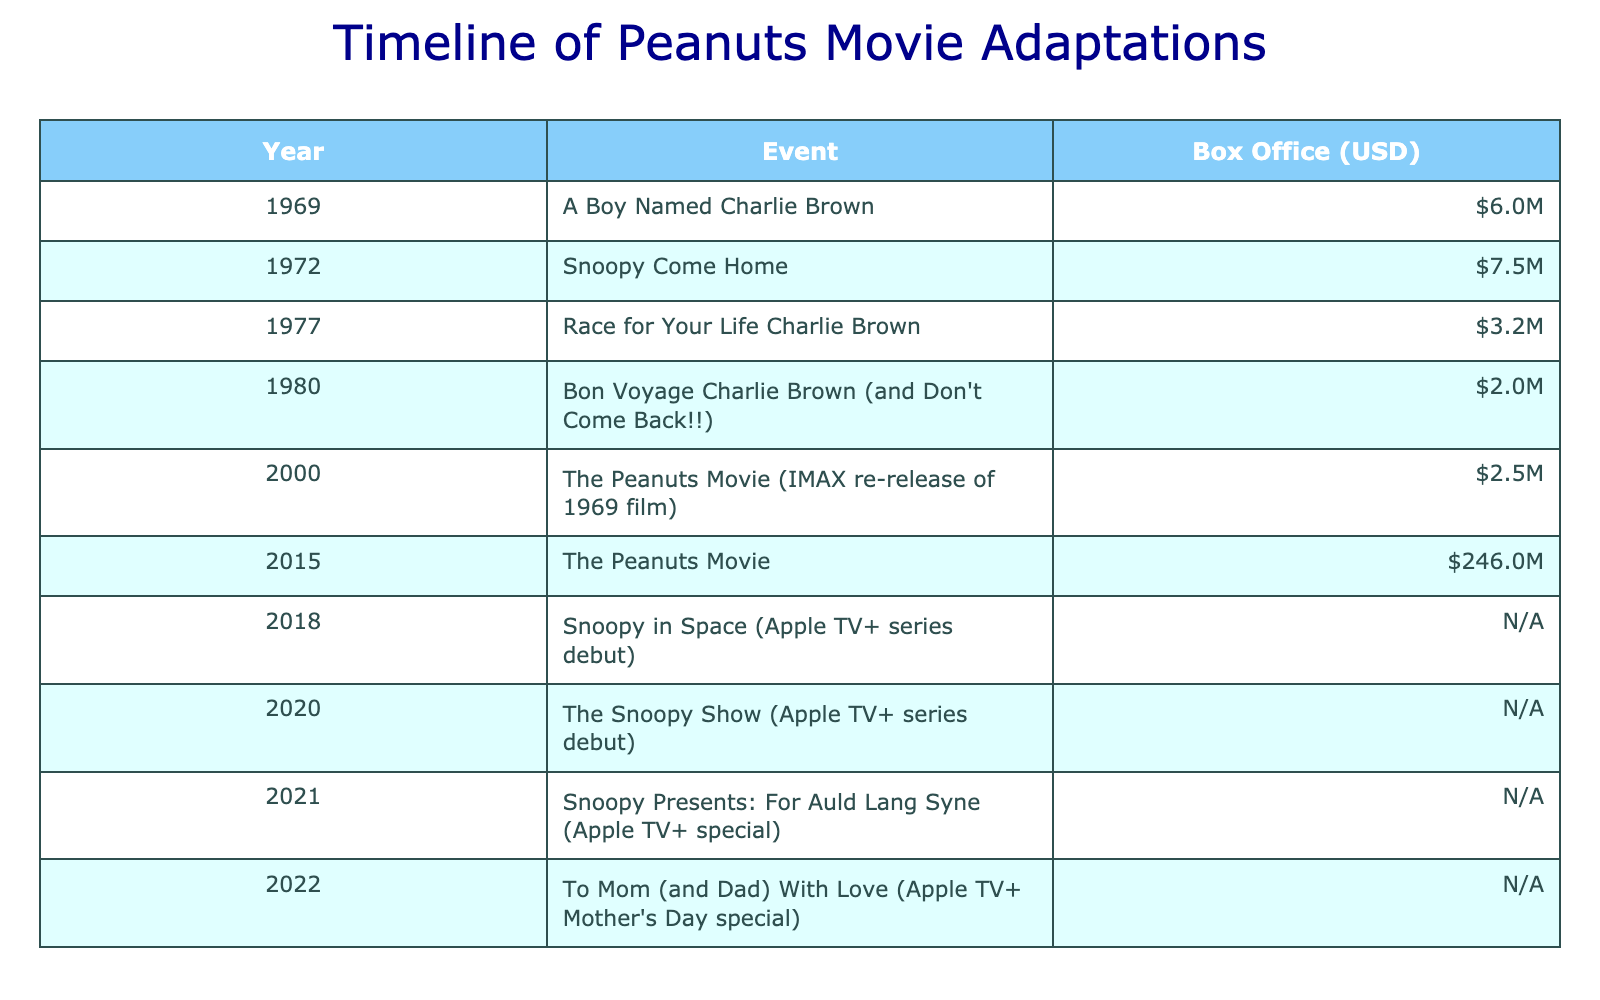What is the box office earnings for "The Peanuts Movie" released in 2015? According to the table, "The Peanuts Movie" was released in 2015 and its box office earnings are listed as 246 million USD.
Answer: 246 million How much did "Snoopy Come Home" earn at the box office? The table indicates that "Snoopy Come Home," released in 1972, earned 7.5 million USD at the box office.
Answer: 7.5 million What event had the lowest box office earnings? By reviewing the box office earnings in the table, "Bon Voyage Charlie Brown (and Don't Come Back!!)" from 1980 had the lowest earnings, at 2 million USD.
Answer: 2 million What is the total box office earnings of all the movies listed in the table? Summing the box office earnings from the movies that have values, we get: 6 + 7.5 + 3.2 + 2 + 2.5 + 246 = 267.2 million USD. Note that the adaptations without earnings are not included in this calculation.
Answer: 267.2 million Was there any movie released after 2000 that had a higher box office than "A Boy Named Charlie Brown"? "A Boy Named Charlie Brown" earned 6 million USD. In the table, "The Peanuts Movie" from 2015 earned 246 million, which is higher. So, yes, there was indeed a movie released after 2000 that had higher earnings.
Answer: Yes Which event had earnings of 3.2 million USD? The table shows that "Race for Your Life Charlie Brown," released in 1977, had the box office earnings of 3.2 million USD.
Answer: Race for Your Life Charlie Brown How many total Peanuts movie adaptations are there in the table? By counting the rows in the table, there are a total of 10 events listed, indicating there are 10 Peanuts movie adaptations included in the data.
Answer: 10 Which Peanuts adaptation was released first, and what were its box office earnings? The first adaptation listed in the table is "A Boy Named Charlie Brown," released in 1969, with box office earnings of 6 million USD.
Answer: A Boy Named Charlie Brown; 6 million Did "To Mom (and Dad) With Love" generate any box office earnings? The table indicates that "To Mom (and Dad) With Love," released in 2022, has "N/A" listed in the box office column, meaning it did not generate any box office earnings.
Answer: No 